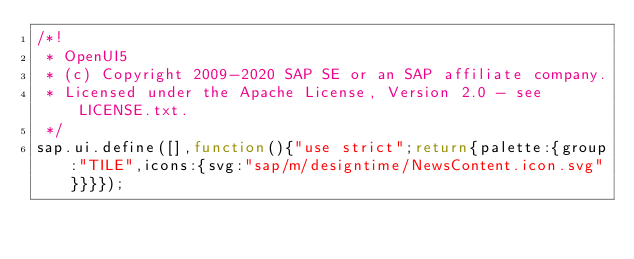Convert code to text. <code><loc_0><loc_0><loc_500><loc_500><_JavaScript_>/*!
 * OpenUI5
 * (c) Copyright 2009-2020 SAP SE or an SAP affiliate company.
 * Licensed under the Apache License, Version 2.0 - see LICENSE.txt.
 */
sap.ui.define([],function(){"use strict";return{palette:{group:"TILE",icons:{svg:"sap/m/designtime/NewsContent.icon.svg"}}}});</code> 